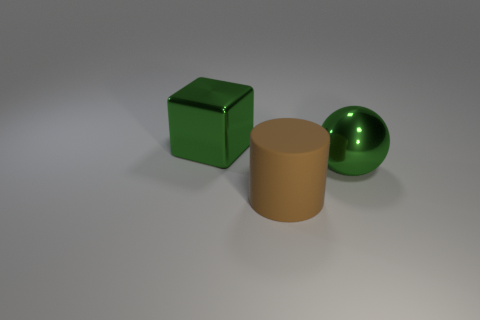Are there any indications of where this scene might be taking place? The scene provides no specific indicators of a location. It seems to be an abstract setup, perhaps in a virtual or simulated environment. The background is neutral and does not resemble any real-world location. 